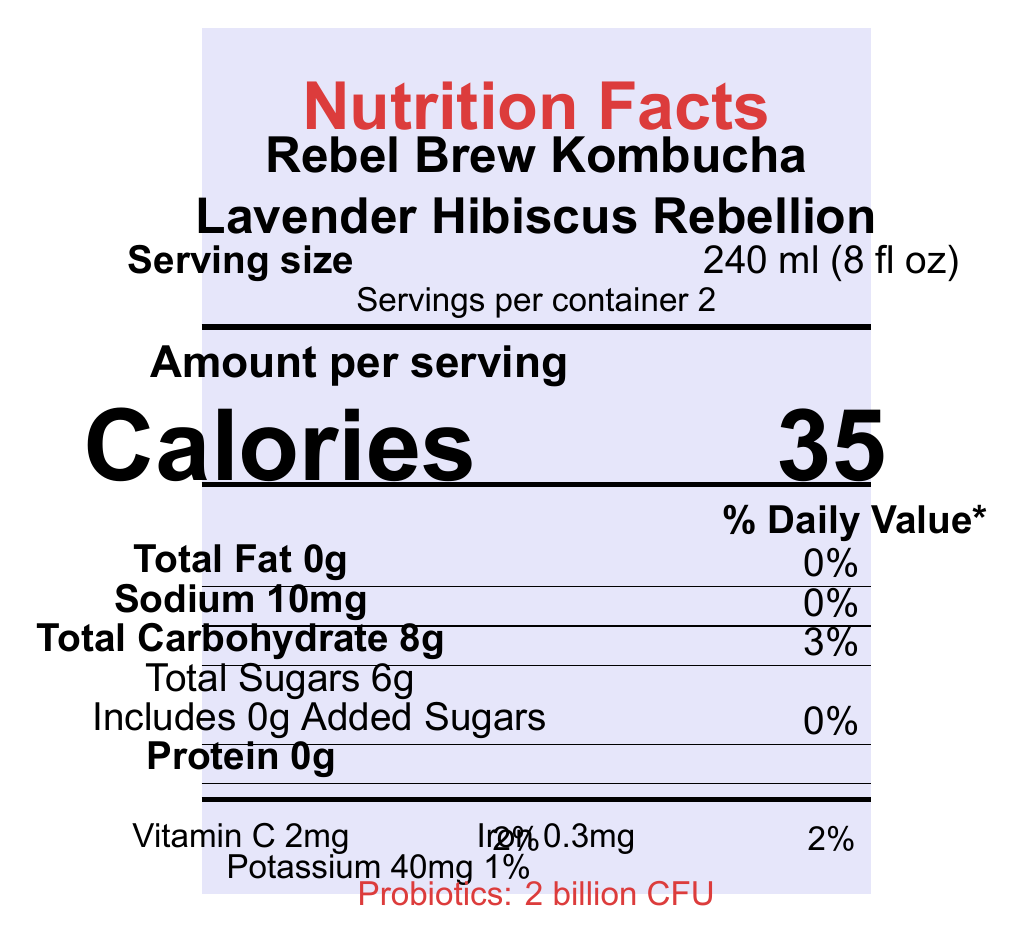what is the serving size? The serving size is explicitly mentioned under the "Serving size" label in the document.
Answer: 240 ml (8 fl oz) how many servings are in each container? The document states "Servings per container 2" directly below the serving size.
Answer: 2 how many calories are there per serving? The "Calories" section specifies there are 35 calories per serving.
Answer: 35 what bold labels are associated with nutrient content? These labels are in bold and indicated with their respective amounts and daily values.
Answer: Total Fat, Sodium, Total Carbohydrate, Protein what percentage of the daily value of potassium does one serving provide? The potassium section lists "Potassium 40mg 1%".
Answer: 1% what is the flavor of Rebel Brew Kombucha? The flavor is mentioned directly under the product name at the top of the document.
Answer: Lavender Hibiscus Rebellion how many grams of total sugars are there per serving? The total sugars amount is clearly stated in the total carbohydrate section.
Answer: 6g does the product contain any added sugars? The amount of added sugars is listed as "0g Included 0g Added Sugars", meaning there are no added sugars.
Answer: No what are the vitamins and minerals listed in the document? A. Vitamin A, Calcium, Iron, Potassium B. Vitamin C, Iron, Potassium C. Vitamin C, Vitamin D, Iron, Calcium The document lists Vitamin C 2mg, Iron 0.3mg, and Potassium 40mg as the vitamins and minerals present.
Answer: B how many grams of protein does one serving contain? A. 0g B. 2g C. 4g The document states "Protein 0g" which means there are no grams of protein per serving.
Answer: A is the kombucha certified organic? The certifications section lists "USDA Organic", indicating the product is certified organic.
Answer: Yes describe the entire document The document provides a comprehensive overview of the nutritional content, ingredients, certifications, and additional product information for Rebel Brew Kombucha.
Answer: The document is a Nutrition Facts label for Rebel Brew Kombucha, specifically the "Lavender Hibiscus Rebellion" flavor. It details the serving size, servings per container, and various nutritional information including calories, fats, sodium, carbohydrates, sugars, protein, vitamins, and probiotics. It also includes information on ingredients, allergen information, and certifications. The packaging and inspiration behind the product are provided, emphasizing sustainable practices and a rebellious spirit. how many calories are in one container? The document provides the calories per serving (35) but does not explicitly state the calories per container. However, knowing there are 2 servings per container, one could infer each container contains 70 calories (2 * 35), though this requires calculation not explicitly provided.
Answer: Cannot be determined what facility processes the kombucha? The document mentions that it is produced in a facility that processes soy and tree nuts, but it does not provide the name or specific location of the facility.
Answer: Not enough information 